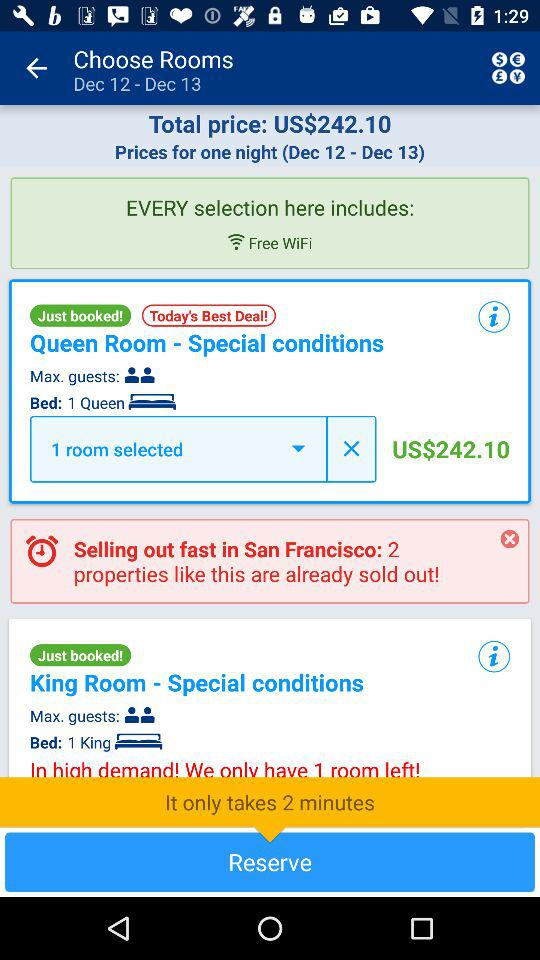What is the size of the bed? The sizes of the beds are queen and king. 